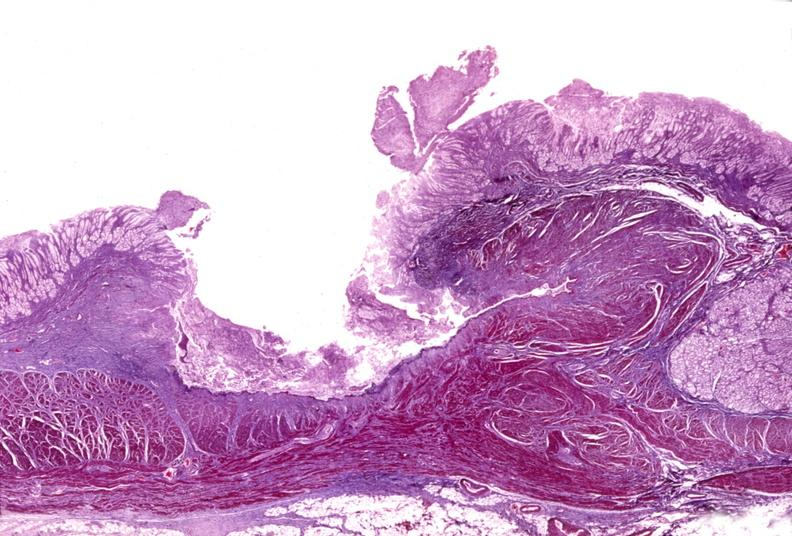what is present?
Answer the question using a single word or phrase. Gastrointestinal 